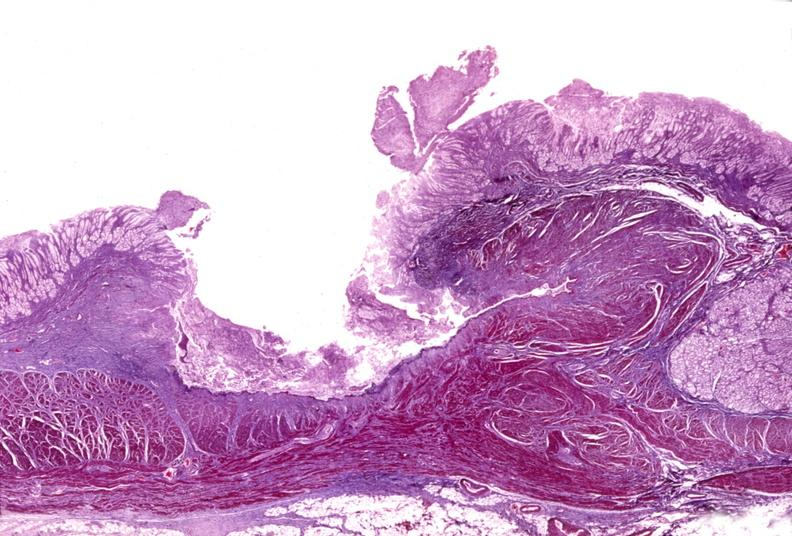what is present?
Answer the question using a single word or phrase. Gastrointestinal 